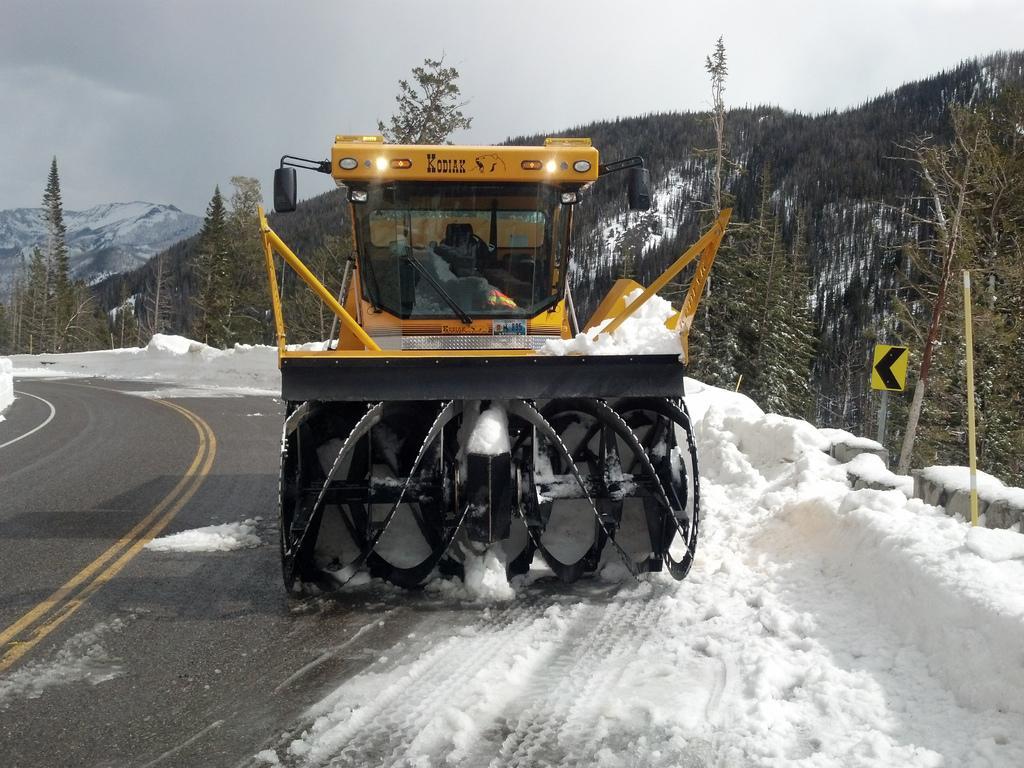Could you give a brief overview of what you see in this image? In this image there are there is vehicle and snow in the foreground. There are trees and mountains in the background. There is a road at the bottom. And there is a sky at the top. 